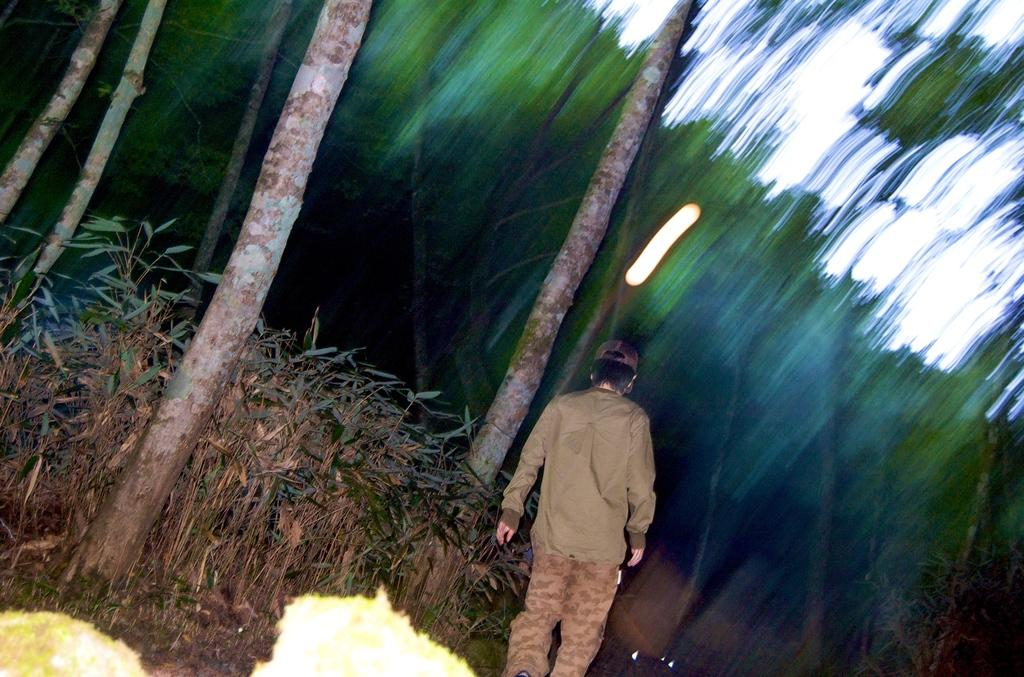What is the main subject of the image? There is a man standing in the image. What is located near the man? There are plants beside the man. What type of vegetation can be seen in the image? There are trees in the image. How would you describe the background of the image? The background of the image is blurred. Can you tell me how many plants the man is touching in the image? There is no indication in the image that the man is touching any plants. 